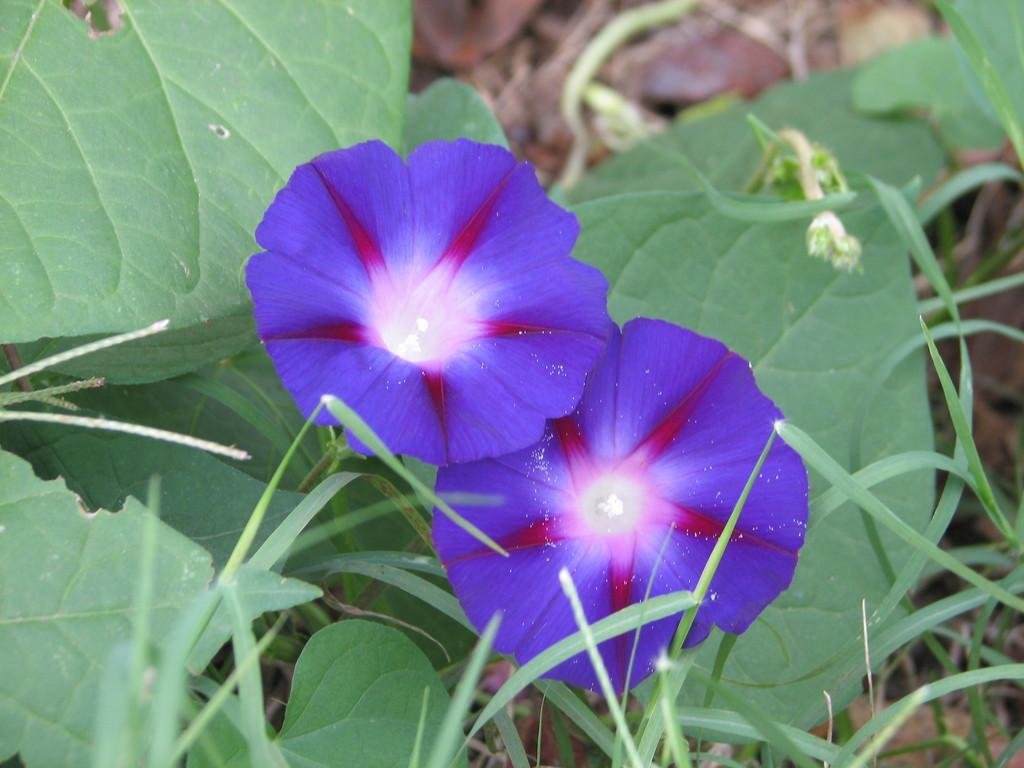What type of flowers are in the foreground of the image? There are two violet colored flowers in the foreground of the image. What is the relationship between the flowers and the plant? The flowers are part of a plant. What can be seen in the background of the image? There are leaves and grass visible in the background of the image. Is there a chair visible in the image? No, there is no chair present in the image. What type of match can be seen in the image? There is no match present in the image. 